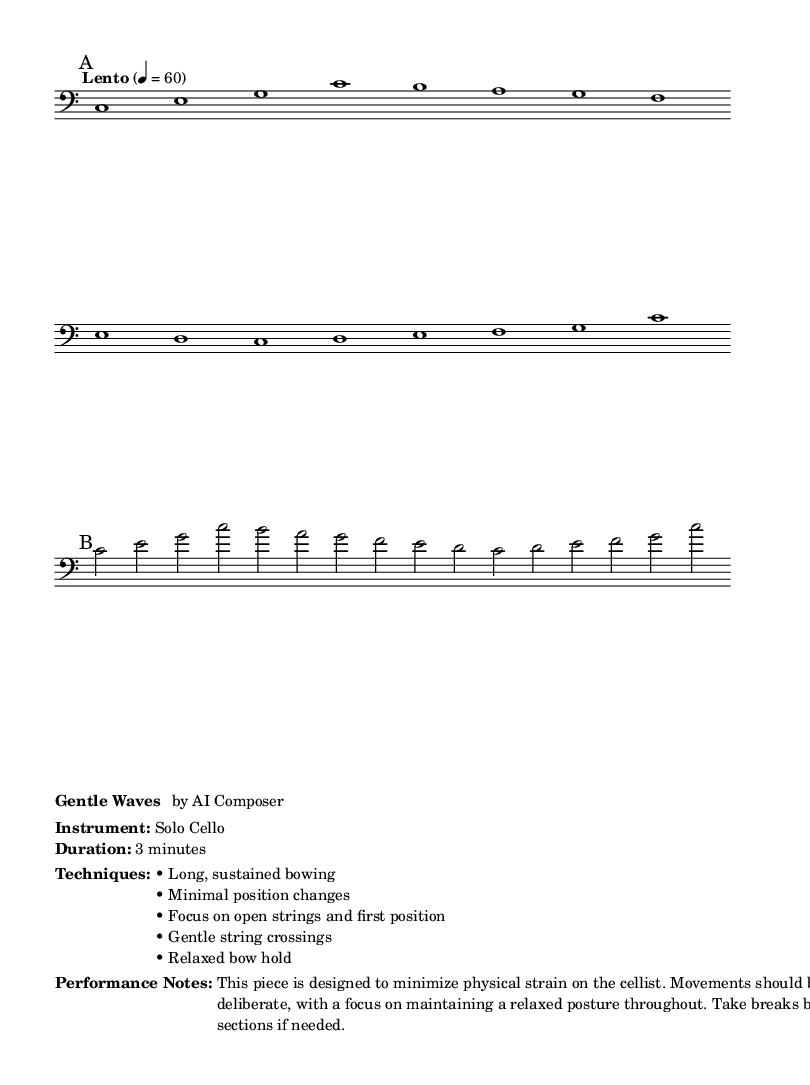What is the time signature of this music? The time signature is indicated in the header of the score, showing that there are four beats in each measure.
Answer: 4/4 What is the key signature of this music? The key signature is displayed at the beginning of the score, which shows that there are no sharps or flats, indicating it is in C major.
Answer: C major What is the tempo marking of this piece? The tempo marking is found near the start of the score and indicates a slow pace, specifically set at 60 beats per minute.
Answer: Lento, 60 How many measures are in section A? Section A is indicated by the mark "A," and by counting the number of measures from the start of A to the break, we find there are 14 measures.
Answer: 14 measures What bowing technique does this piece focus on? The performance notes indicate that the piece emphasizes long, sustained bowing as a primary technique to minimize strain.
Answer: Long, sustained bowing What position changes are suggested in this piece? The performance notes specify minimal position changes, which guides the player to remain mostly in the first position.
Answer: Minimal position changes 